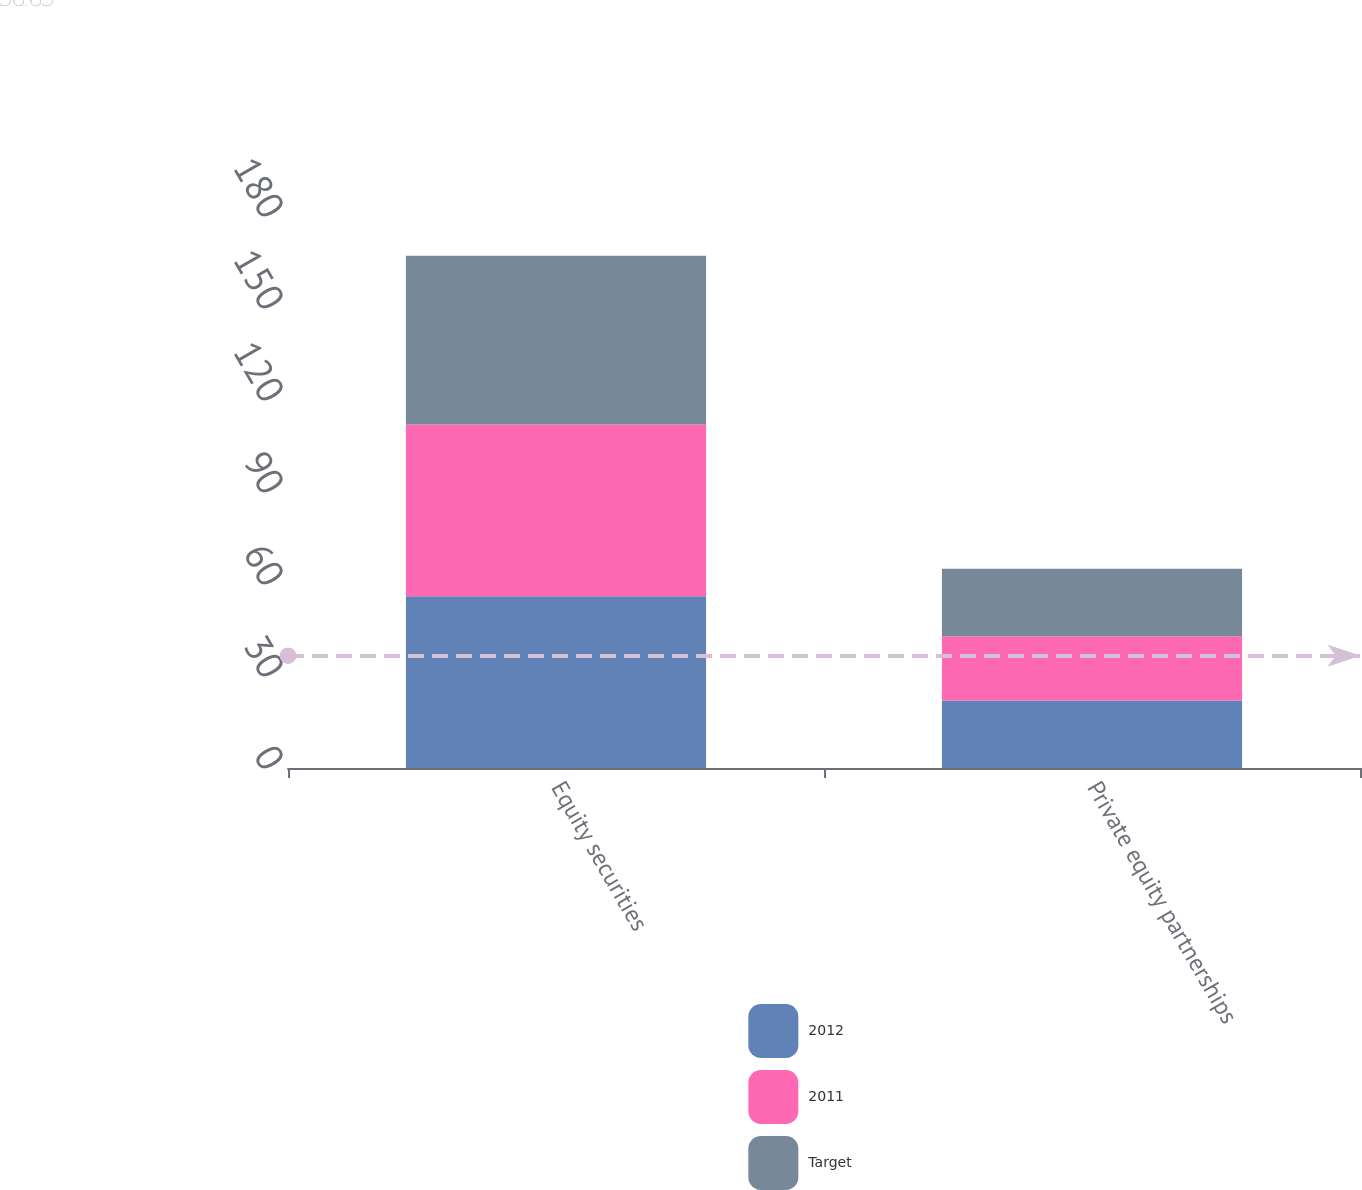<chart> <loc_0><loc_0><loc_500><loc_500><stacked_bar_chart><ecel><fcel>Equity securities<fcel>Private equity partnerships<nl><fcel>2012<fcel>56<fcel>22<nl><fcel>2011<fcel>56<fcel>21<nl><fcel>Target<fcel>55<fcel>22<nl></chart> 